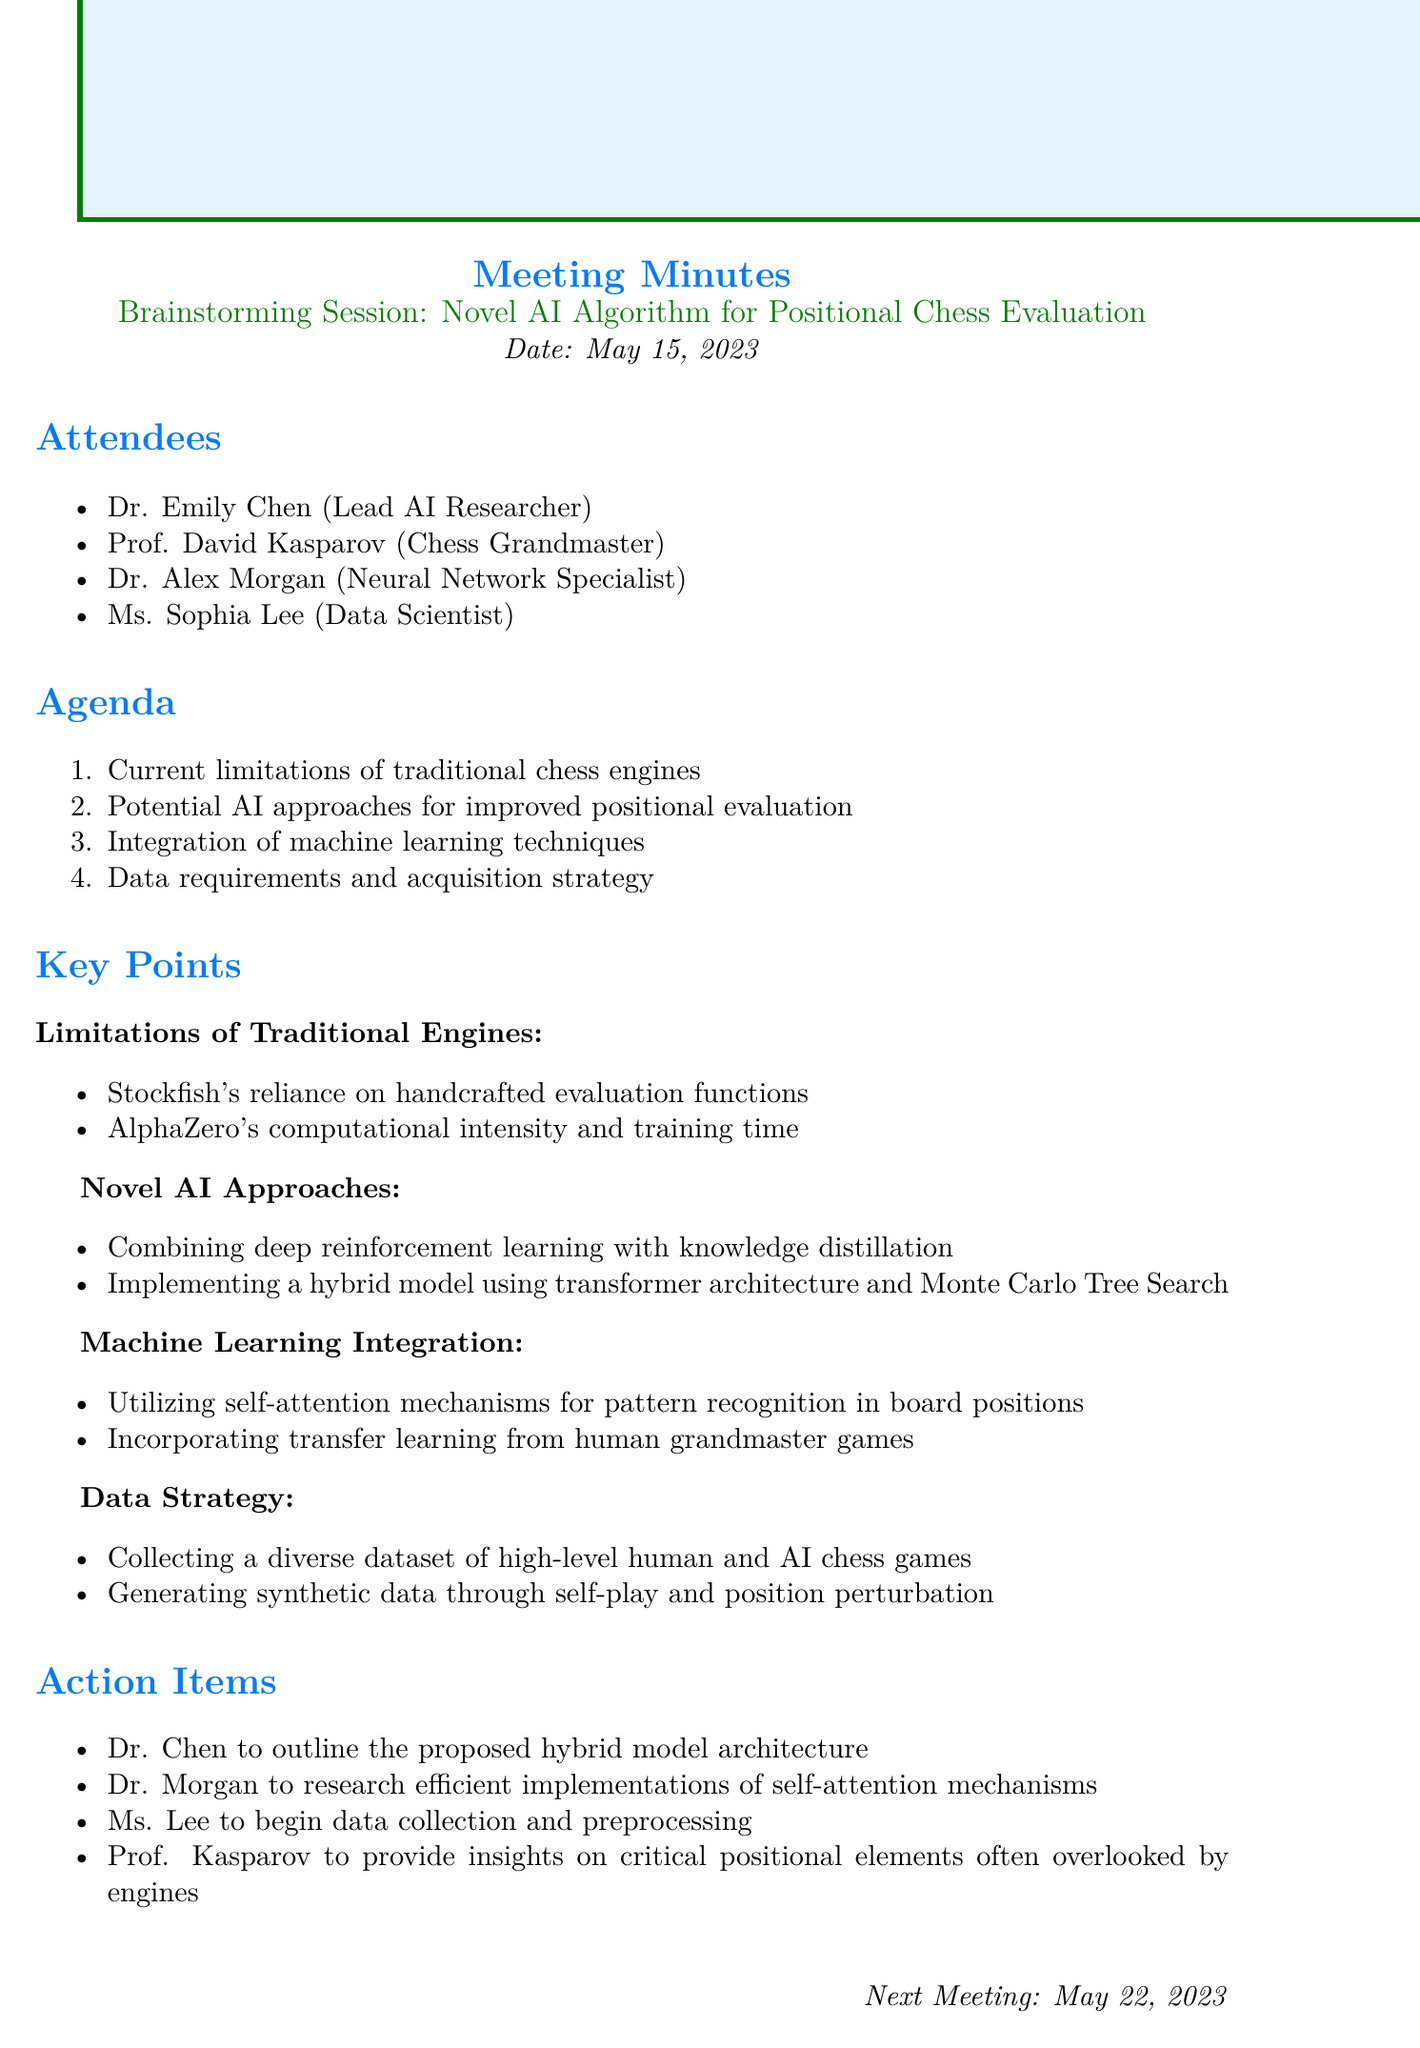What is the meeting title? The meeting title is the descriptive heading given at the top of the minutes, which summarizes the session's focus.
Answer: Brainstorming Session: Novel AI Algorithm for Positional Chess Evaluation Who are the attendees? The attendees list names the participants in the meeting, which reflects their respective roles.
Answer: Dr. Emily Chen, Prof. David Kasparov, Dr. Alex Morgan, Ms. Sophia Lee What is the date of the meeting? The date indicates when the meeting took place, which is important for context.
Answer: May 15, 2023 What is one limitation of traditional chess engines mentioned? This question requires recalling specific details under the limitations section, showcasing the weaknesses of existing engines.
Answer: Stockfish's reliance on handcrafted evaluation functions What is one novel AI approach proposed in the meeting? The answer reflects the session's exploration of innovative methodologies to enhance chess algorithm performance.
Answer: Combining deep reinforcement learning with knowledge distillation Who is responsible for outlining the proposed hybrid model architecture? This question aims to clarify the action items designated to specific attendees, ensuring accountability in tasks.
Answer: Dr. Chen What is the next meeting date? This indicates when the follow-up discussion is scheduled, which is relevant for tracking the project's progress.
Answer: May 22, 2023 What research area is Dr. Morgan assigned to explore? This reflects the action items discussed during the meeting, focusing on the participants' specific contributions.
Answer: Efficient implementations of self-attention mechanisms How will data be collected according to the given strategy? This elaborates on the strategy outlined for gathering necessary data to support the algorithm development process.
Answer: Collecting a diverse dataset of high-level human and AI chess games 